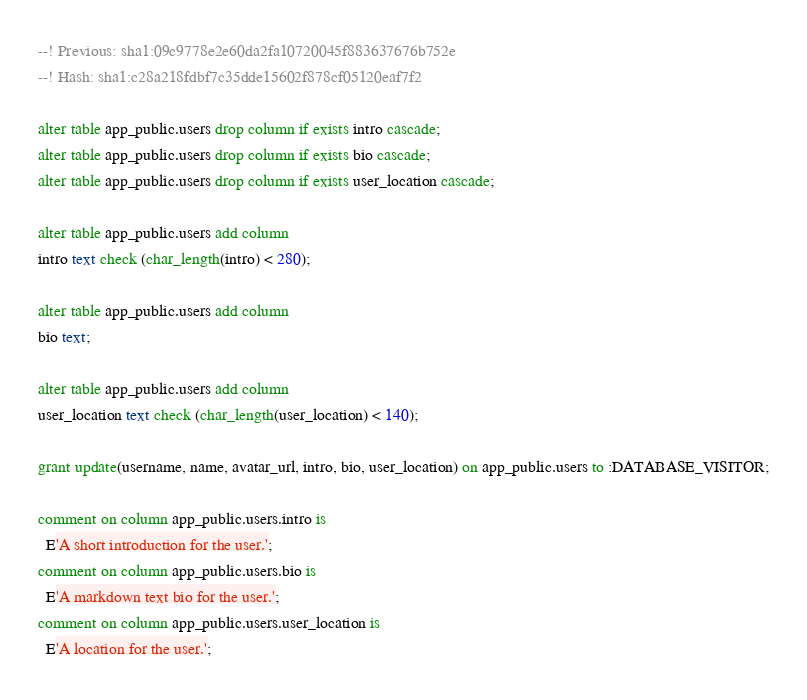Convert code to text. <code><loc_0><loc_0><loc_500><loc_500><_SQL_>--! Previous: sha1:09c9778e2e60da2fa10720045f883637676b752e
--! Hash: sha1:c28a218fdbf7c35dde15602f878cf05120eaf7f2

alter table app_public.users drop column if exists intro cascade;
alter table app_public.users drop column if exists bio cascade;
alter table app_public.users drop column if exists user_location cascade;

alter table app_public.users add column
intro text check (char_length(intro) < 280);

alter table app_public.users add column
bio text;

alter table app_public.users add column
user_location text check (char_length(user_location) < 140);

grant update(username, name, avatar_url, intro, bio, user_location) on app_public.users to :DATABASE_VISITOR;

comment on column app_public.users.intro is
  E'A short introduction for the user.';
comment on column app_public.users.bio is
  E'A markdown text bio for the user.';
comment on column app_public.users.user_location is
  E'A location for the user.';
</code> 